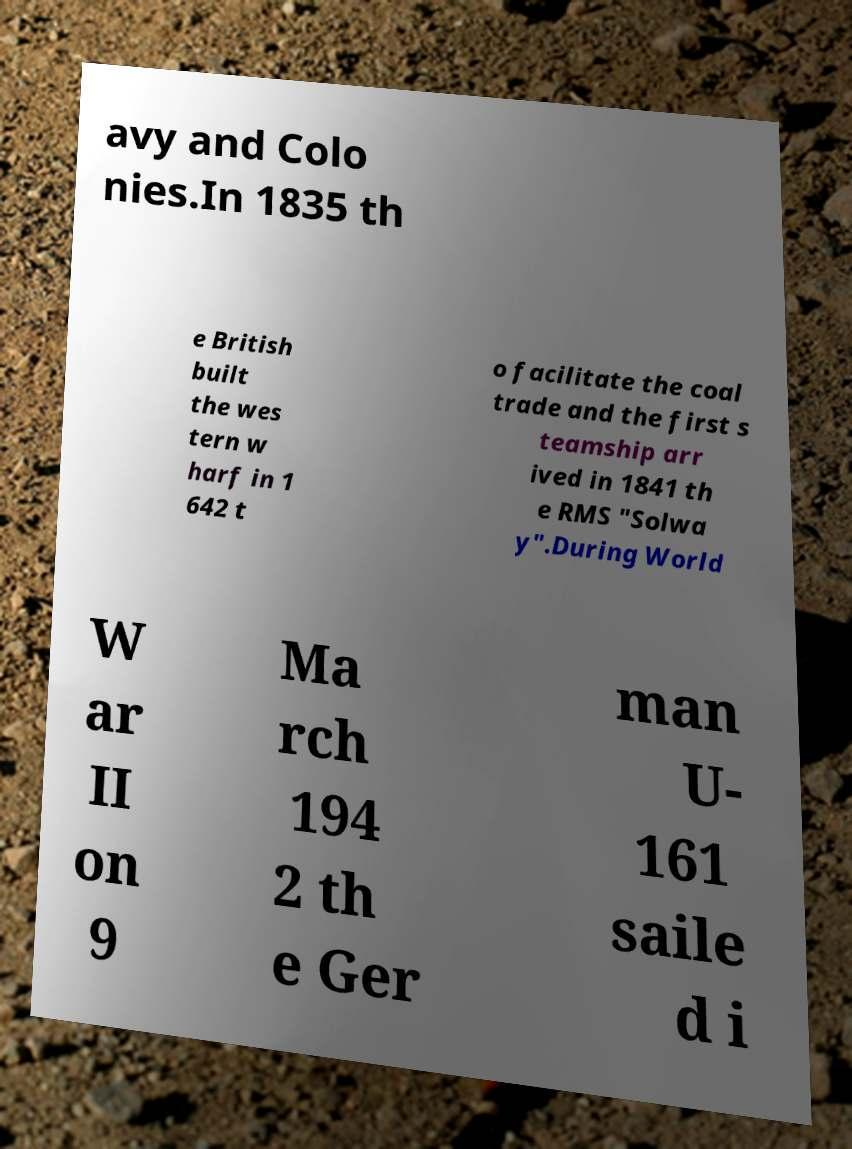Please read and relay the text visible in this image. What does it say? avy and Colo nies.In 1835 th e British built the wes tern w harf in 1 642 t o facilitate the coal trade and the first s teamship arr ived in 1841 th e RMS "Solwa y".During World W ar II on 9 Ma rch 194 2 th e Ger man U- 161 saile d i 